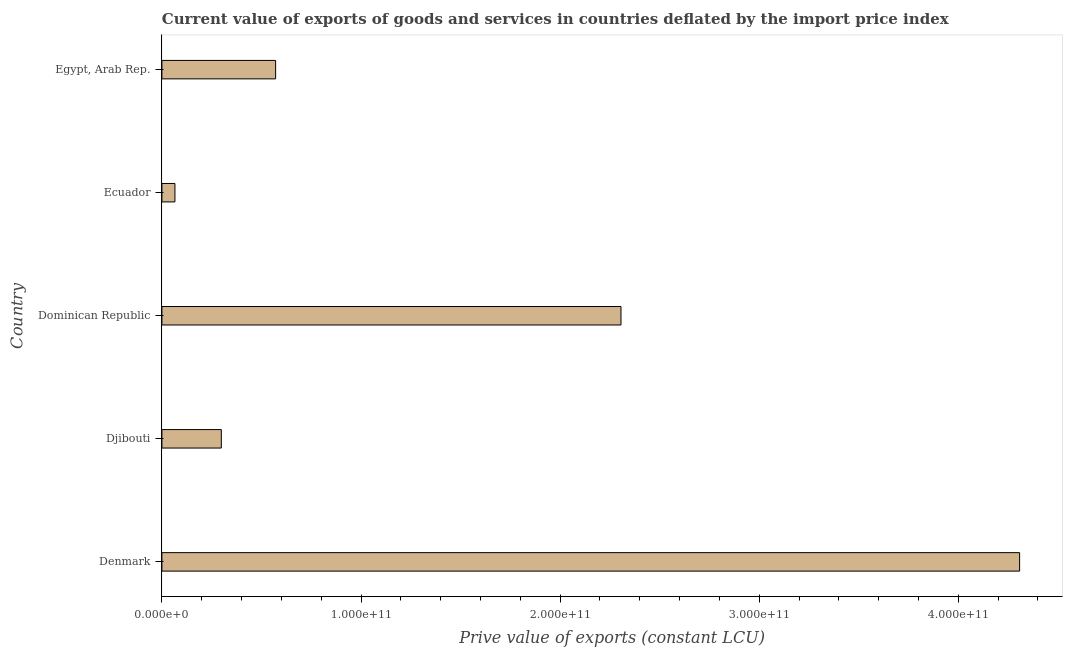What is the title of the graph?
Keep it short and to the point. Current value of exports of goods and services in countries deflated by the import price index. What is the label or title of the X-axis?
Offer a very short reply. Prive value of exports (constant LCU). What is the price value of exports in Denmark?
Provide a short and direct response. 4.31e+11. Across all countries, what is the maximum price value of exports?
Your answer should be very brief. 4.31e+11. Across all countries, what is the minimum price value of exports?
Your response must be concise. 6.55e+09. In which country was the price value of exports maximum?
Ensure brevity in your answer.  Denmark. In which country was the price value of exports minimum?
Ensure brevity in your answer.  Ecuador. What is the sum of the price value of exports?
Provide a succinct answer. 7.55e+11. What is the difference between the price value of exports in Djibouti and Ecuador?
Provide a short and direct response. 2.33e+1. What is the average price value of exports per country?
Make the answer very short. 1.51e+11. What is the median price value of exports?
Keep it short and to the point. 5.71e+1. What is the ratio of the price value of exports in Denmark to that in Ecuador?
Your answer should be compact. 65.8. Is the difference between the price value of exports in Dominican Republic and Ecuador greater than the difference between any two countries?
Make the answer very short. No. What is the difference between the highest and the second highest price value of exports?
Offer a terse response. 2.00e+11. What is the difference between the highest and the lowest price value of exports?
Keep it short and to the point. 4.24e+11. In how many countries, is the price value of exports greater than the average price value of exports taken over all countries?
Keep it short and to the point. 2. How many bars are there?
Your answer should be compact. 5. How many countries are there in the graph?
Your answer should be compact. 5. What is the difference between two consecutive major ticks on the X-axis?
Offer a terse response. 1.00e+11. Are the values on the major ticks of X-axis written in scientific E-notation?
Your response must be concise. Yes. What is the Prive value of exports (constant LCU) in Denmark?
Offer a terse response. 4.31e+11. What is the Prive value of exports (constant LCU) in Djibouti?
Your answer should be compact. 2.98e+1. What is the Prive value of exports (constant LCU) of Dominican Republic?
Your answer should be very brief. 2.31e+11. What is the Prive value of exports (constant LCU) in Ecuador?
Provide a succinct answer. 6.55e+09. What is the Prive value of exports (constant LCU) in Egypt, Arab Rep.?
Give a very brief answer. 5.71e+1. What is the difference between the Prive value of exports (constant LCU) in Denmark and Djibouti?
Give a very brief answer. 4.01e+11. What is the difference between the Prive value of exports (constant LCU) in Denmark and Dominican Republic?
Give a very brief answer. 2.00e+11. What is the difference between the Prive value of exports (constant LCU) in Denmark and Ecuador?
Keep it short and to the point. 4.24e+11. What is the difference between the Prive value of exports (constant LCU) in Denmark and Egypt, Arab Rep.?
Give a very brief answer. 3.74e+11. What is the difference between the Prive value of exports (constant LCU) in Djibouti and Dominican Republic?
Make the answer very short. -2.01e+11. What is the difference between the Prive value of exports (constant LCU) in Djibouti and Ecuador?
Ensure brevity in your answer.  2.33e+1. What is the difference between the Prive value of exports (constant LCU) in Djibouti and Egypt, Arab Rep.?
Your answer should be very brief. -2.73e+1. What is the difference between the Prive value of exports (constant LCU) in Dominican Republic and Ecuador?
Make the answer very short. 2.24e+11. What is the difference between the Prive value of exports (constant LCU) in Dominican Republic and Egypt, Arab Rep.?
Give a very brief answer. 1.73e+11. What is the difference between the Prive value of exports (constant LCU) in Ecuador and Egypt, Arab Rep.?
Offer a very short reply. -5.06e+1. What is the ratio of the Prive value of exports (constant LCU) in Denmark to that in Djibouti?
Offer a terse response. 14.44. What is the ratio of the Prive value of exports (constant LCU) in Denmark to that in Dominican Republic?
Give a very brief answer. 1.87. What is the ratio of the Prive value of exports (constant LCU) in Denmark to that in Ecuador?
Keep it short and to the point. 65.8. What is the ratio of the Prive value of exports (constant LCU) in Denmark to that in Egypt, Arab Rep.?
Offer a very short reply. 7.54. What is the ratio of the Prive value of exports (constant LCU) in Djibouti to that in Dominican Republic?
Give a very brief answer. 0.13. What is the ratio of the Prive value of exports (constant LCU) in Djibouti to that in Ecuador?
Ensure brevity in your answer.  4.56. What is the ratio of the Prive value of exports (constant LCU) in Djibouti to that in Egypt, Arab Rep.?
Make the answer very short. 0.52. What is the ratio of the Prive value of exports (constant LCU) in Dominican Republic to that in Ecuador?
Your answer should be very brief. 35.22. What is the ratio of the Prive value of exports (constant LCU) in Dominican Republic to that in Egypt, Arab Rep.?
Offer a very short reply. 4.04. What is the ratio of the Prive value of exports (constant LCU) in Ecuador to that in Egypt, Arab Rep.?
Ensure brevity in your answer.  0.12. 